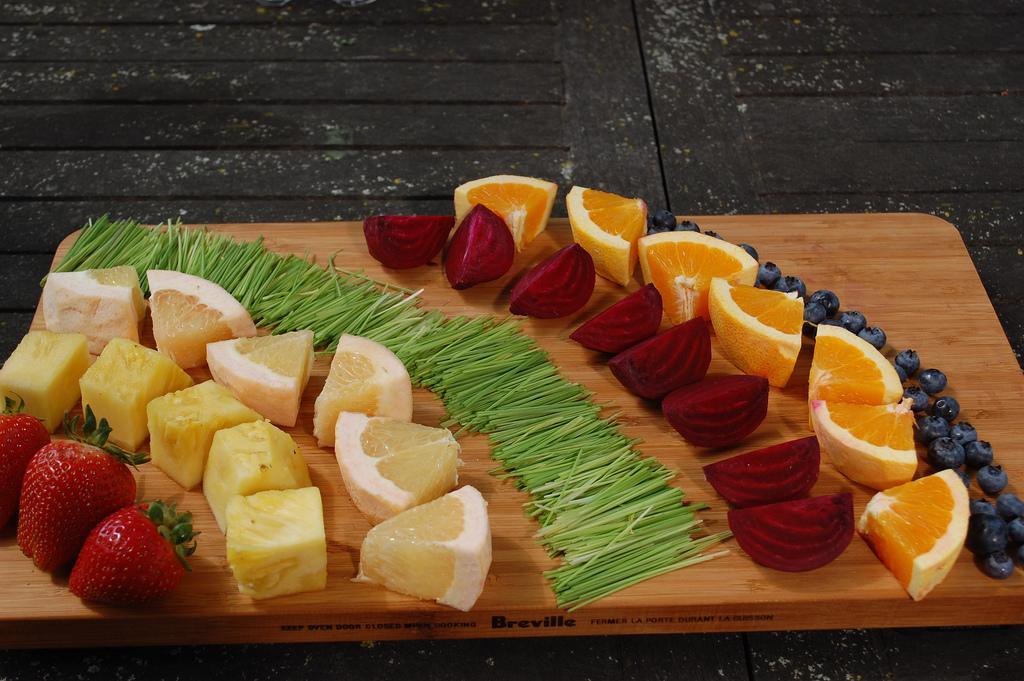Could you give a brief overview of what you see in this image? In this picture, we can see some food items on the wooden surface, and we can see the wooden surface on the black object. 